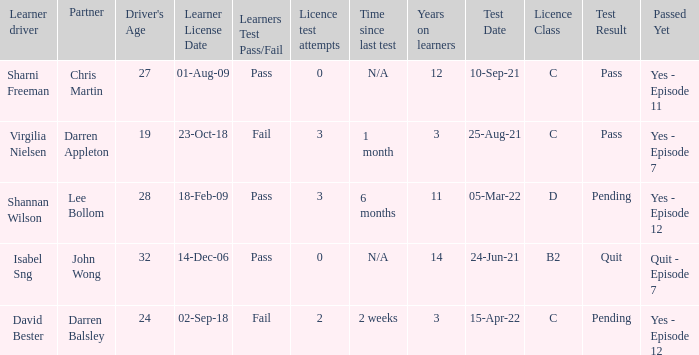Which driver is older than 24 and has more than 0 licence test attempts? Shannan Wilson. 